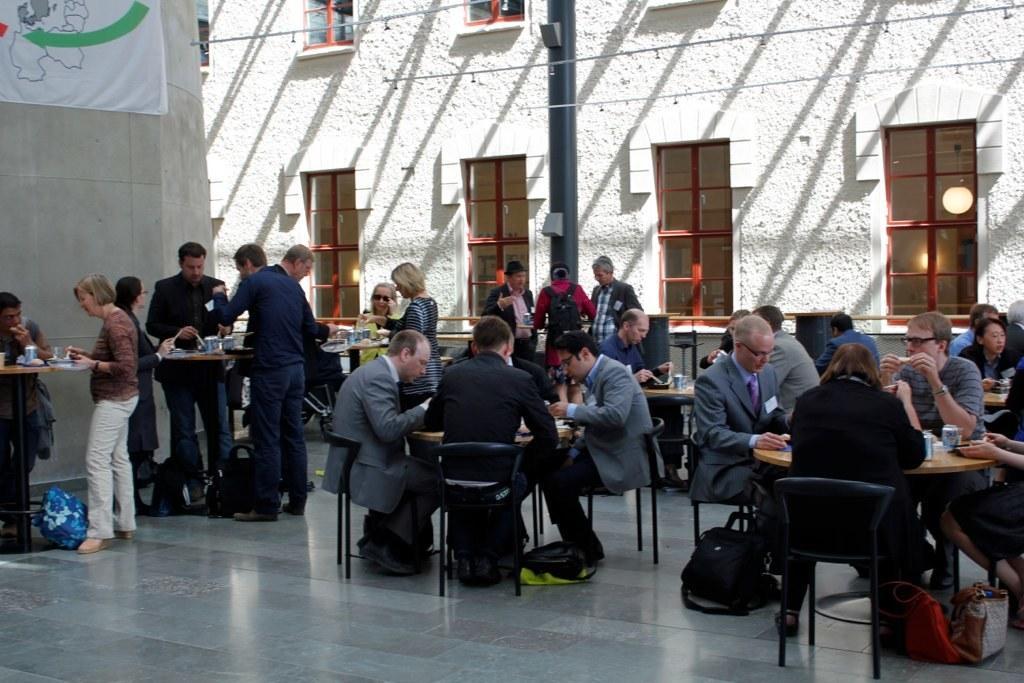How would you summarize this image in a sentence or two? In this image I can see group of people. Among them some people are sitting and some of them are standing. In-front of them there is a table with food on it and these people are eating the food. I can also see many bags on the floor. In the background there is a banner with wall attached. I can also see the building with windows and there is a lamp inside of the building. 